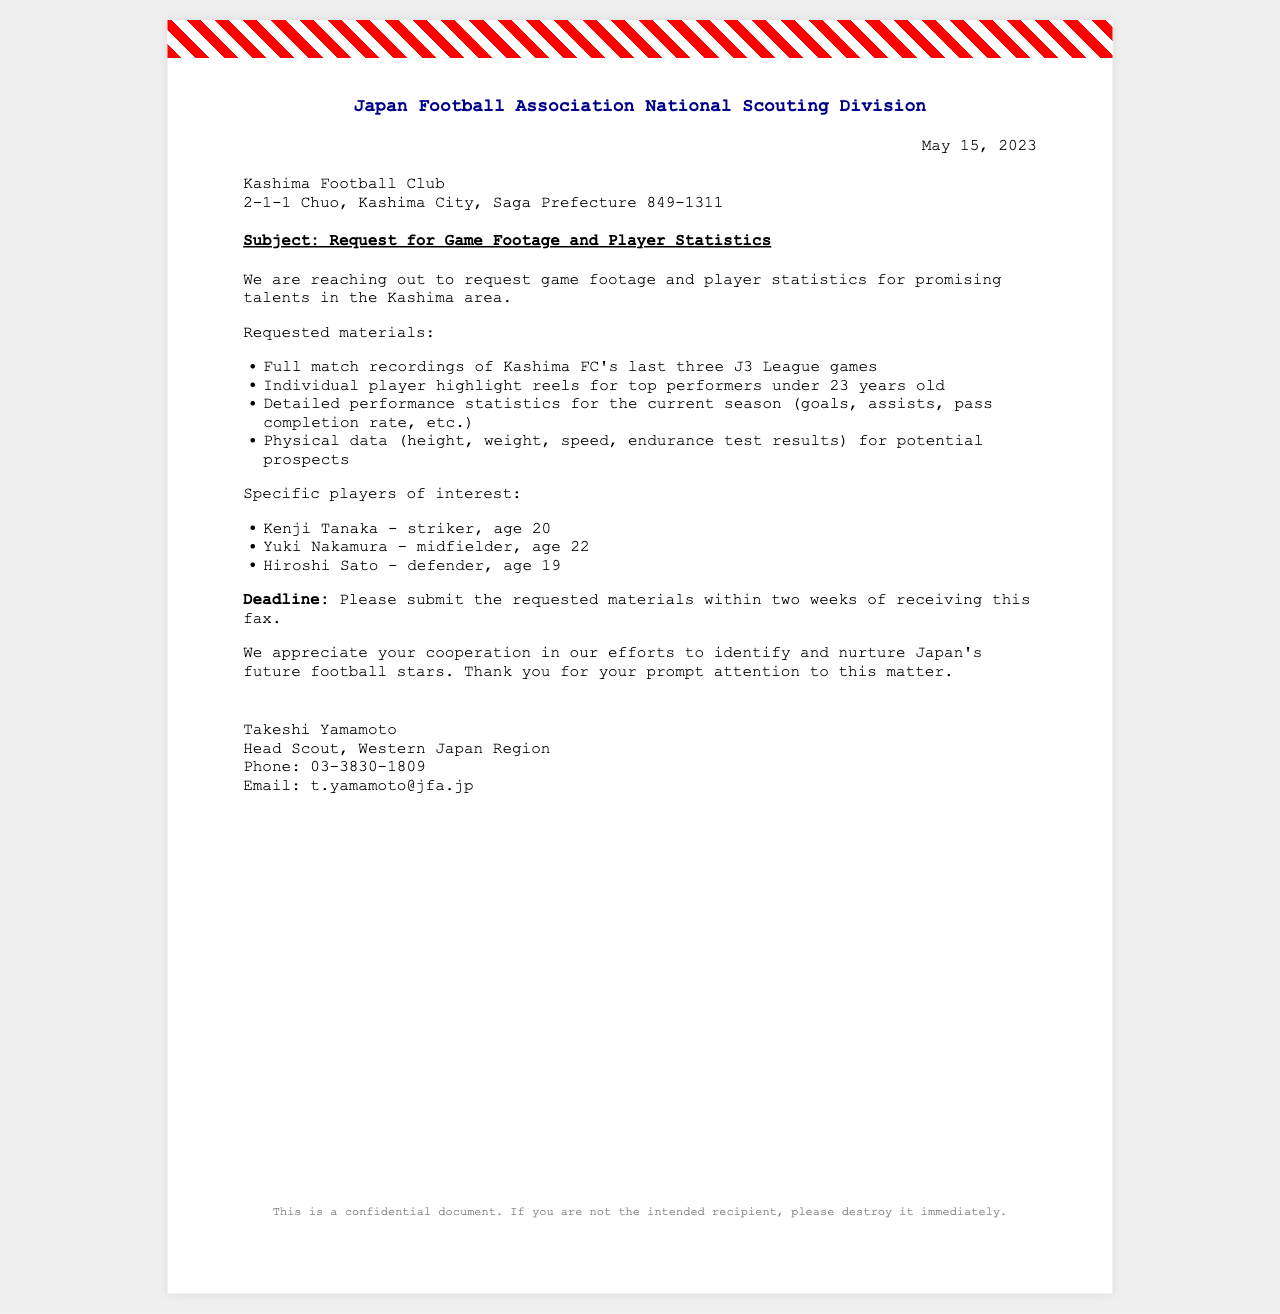What is the date of the fax? The date of the fax is clearly stated in the document.
Answer: May 15, 2023 What club is receiving this fax? The fax specifies the club to which the request is directed.
Answer: Kashima Football Club Who is the head scout mentioned in the fax? The name of the head scout is included in the signature section of the document.
Answer: Takeshi Yamamoto What is the deadline for submitting the requested materials? The deadline for submission is mentioned explicitly in the content of the fax.
Answer: Two weeks What type of data is requested for potential prospects? The request includes specific types of data regarding players, found in the content section.
Answer: Physical data How many players are specifically mentioned in the fax? The document lists the number of players of interest under specific mentions.
Answer: Three What league's games are the footage requests concerning? The document specifies which league's match recordings are requested.
Answer: J3 League What is the email address provided for further contact? The email address is part of the contact information at the end of the fax.
Answer: t.yamamoto@jfa.jp What is one of the requested materials for prominent under-23 players? The content outlines specific materials requested, including types of video content.
Answer: Individual player highlight reels 